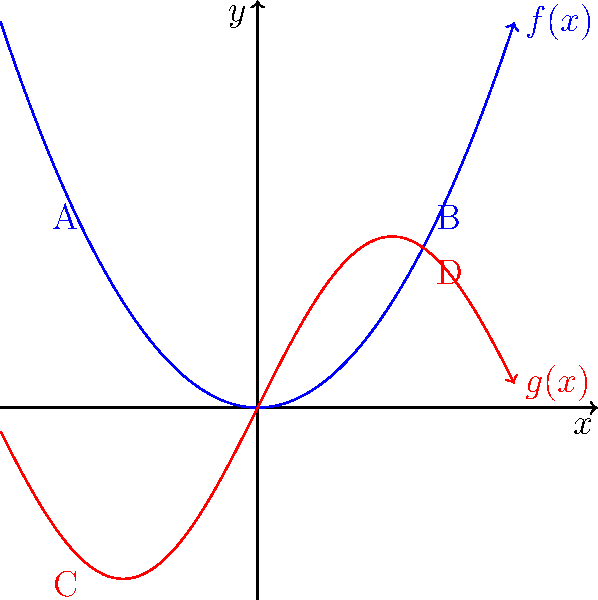Consider the two curves representing migration routes during the Great Migration: $f(x) = 0.5x^2$ (blue) and $g(x) = 2\sin(x)$ (red). Are these routes homotopy equivalent in the context of the Great Migration's impact on Southern society? To determine if the migration routes are homotopy equivalent, we need to follow these steps:

1. Understand homotopy equivalence: Two continuous functions are homotopy equivalent if one can be continuously deformed into the other without breaking.

2. Analyze the functions:
   $f(x) = 0.5x^2$ (blue curve)
   $g(x) = 2\sin(x)$ (red curve)

3. Consider the domain and range:
   Both functions are continuous on the entire real line.
   $f(x)$ is always non-negative and unbounded.
   $g(x)$ is bounded between -2 and 2.

4. Examine endpoints:
   $f(x)$ starts at A and ends at B, both positive y-values.
   $g(x)$ starts at C and ends at D, with C negative and D positive.

5. Evaluate deformation possibility:
   - $f(x)$ cannot be continuously deformed into $g(x)$ because:
     a) $f(x)$ is unbounded while $g(x)$ is bounded.
     b) The endpoints of $f(x)$ and $g(x)$ don't align.
     c) $f(x)$ is always non-negative, while $g(x)$ oscillates between positive and negative values.

6. Historical context:
   In the Great Migration, the blue curve ($f(x)$) might represent a continuous, increasing flow of migrants from the South to the North, while the red curve ($g(x)$) could represent fluctuating migration patterns influenced by economic cycles or societal changes.

7. Conclusion:
   These routes are not homotopy equivalent, reflecting the complex and varied nature of migration patterns during the Great Migration and their differing impacts on Southern society.
Answer: Not homotopy equivalent 